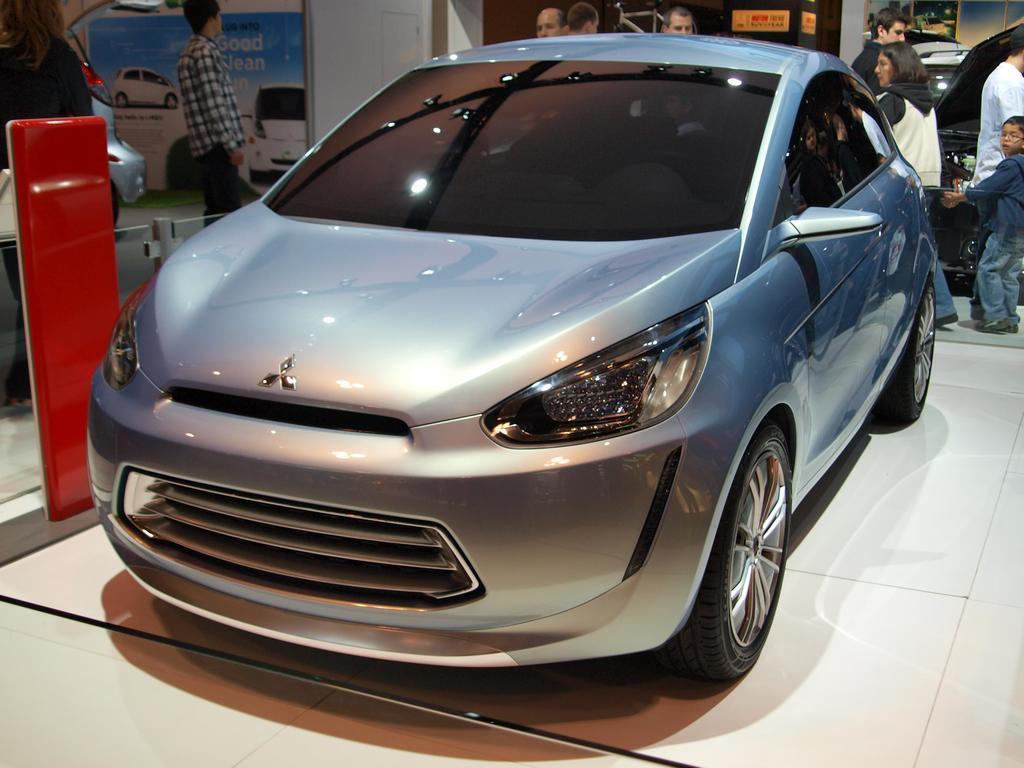Please provide a concise description of this image. In this image I can see a car in the center of the image I can see some people behind the car. I can see some other cars and banners with the cars at the top of the image. 